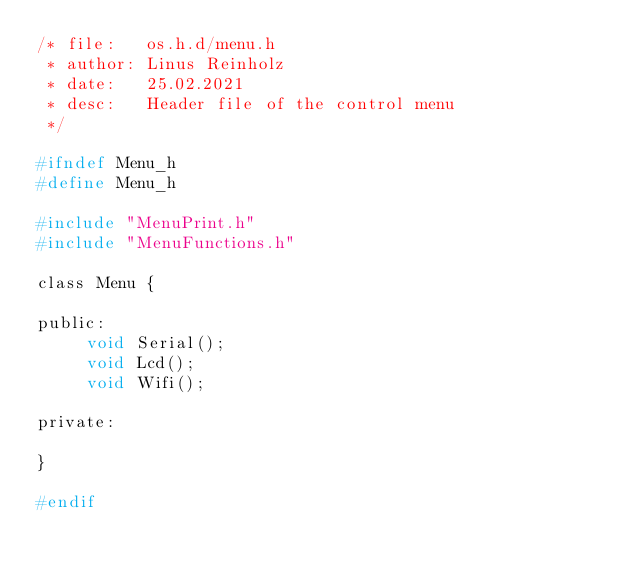Convert code to text. <code><loc_0><loc_0><loc_500><loc_500><_C_>/* file:   os.h.d/menu.h
 * author: Linus Reinholz
 * date:   25.02.2021
 * desc:   Header file of the control menu
 */

#ifndef Menu_h
#define Menu_h

#include "MenuPrint.h"
#include "MenuFunctions.h"

class Menu {

public:
     void Serial();
     void Lcd();
     void Wifi();
     
private:

}

#endif
</code> 